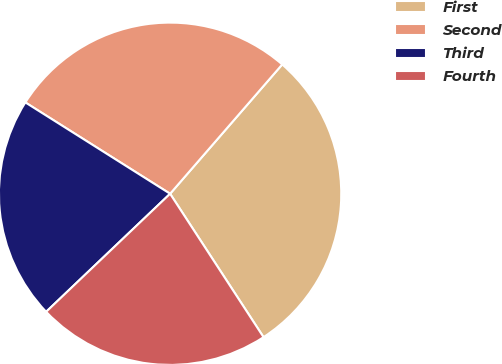Convert chart to OTSL. <chart><loc_0><loc_0><loc_500><loc_500><pie_chart><fcel>First<fcel>Second<fcel>Third<fcel>Fourth<nl><fcel>29.44%<fcel>27.41%<fcel>21.07%<fcel>22.08%<nl></chart> 